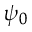<formula> <loc_0><loc_0><loc_500><loc_500>\psi _ { 0 }</formula> 